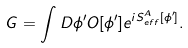Convert formula to latex. <formula><loc_0><loc_0><loc_500><loc_500>G = \int D \phi ^ { \prime } O [ \phi ^ { \prime } ] e ^ { i S _ { e f f } ^ { A } [ \phi ^ { \prime } ] } .</formula> 